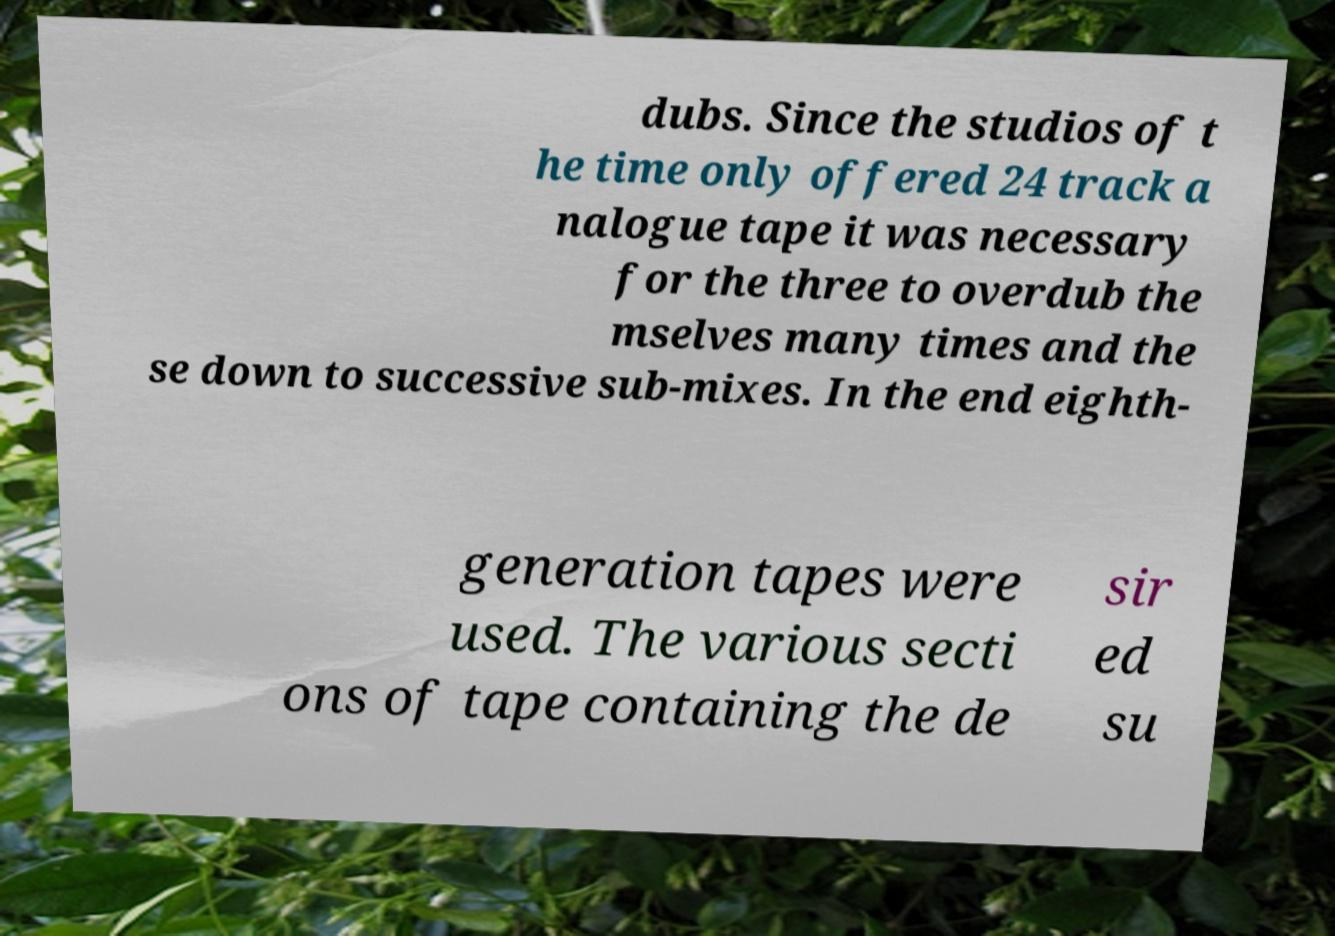Can you read and provide the text displayed in the image?This photo seems to have some interesting text. Can you extract and type it out for me? dubs. Since the studios of t he time only offered 24 track a nalogue tape it was necessary for the three to overdub the mselves many times and the se down to successive sub-mixes. In the end eighth- generation tapes were used. The various secti ons of tape containing the de sir ed su 